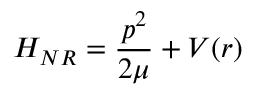<formula> <loc_0><loc_0><loc_500><loc_500>H _ { N R } = { \frac { p ^ { 2 } } { 2 \mu } } + V ( r )</formula> 